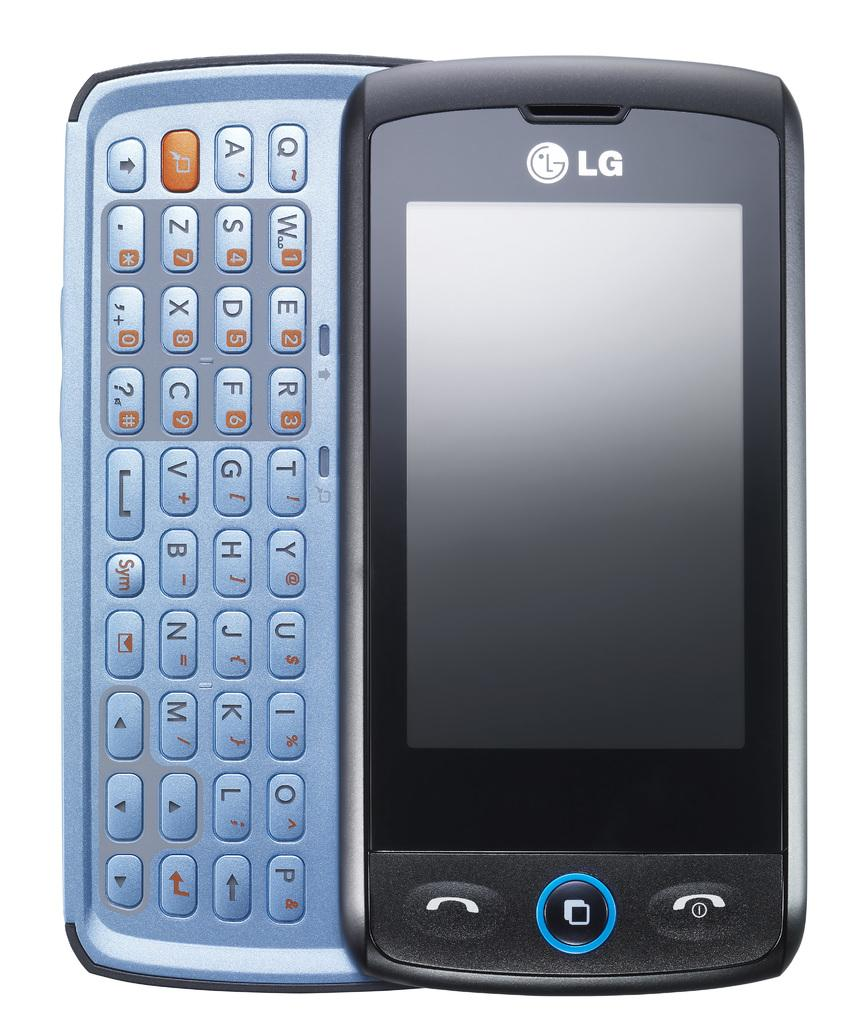Provide a one-sentence caption for the provided image. An LG phone has a black face and a blue keyboard. 